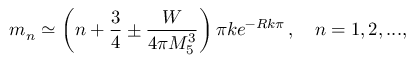Convert formula to latex. <formula><loc_0><loc_0><loc_500><loc_500>m _ { n } \simeq \left ( n + \frac { 3 } { 4 } \pm \frac { W } { 4 \pi M _ { 5 } ^ { 3 } } \right ) \pi k e ^ { - R k \pi } \, , \quad n = 1 , 2 , \dots ,</formula> 